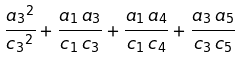<formula> <loc_0><loc_0><loc_500><loc_500>\frac { { a _ { 3 } } ^ { 2 } } { { { { c } _ { 3 } } } ^ { 2 } } + \frac { { a _ { 1 } } \, { a _ { 3 } } } { { { c } _ { 1 } } \, { { c } _ { 3 } } } + \frac { { a _ { 1 } } \, { a _ { 4 } } } { { { c } _ { 1 } } \, { { c } _ { 4 } } } + \frac { { a _ { 3 } } \, { a _ { 5 } } } { { { c } _ { 3 } } \, { { c } _ { 5 } } }</formula> 